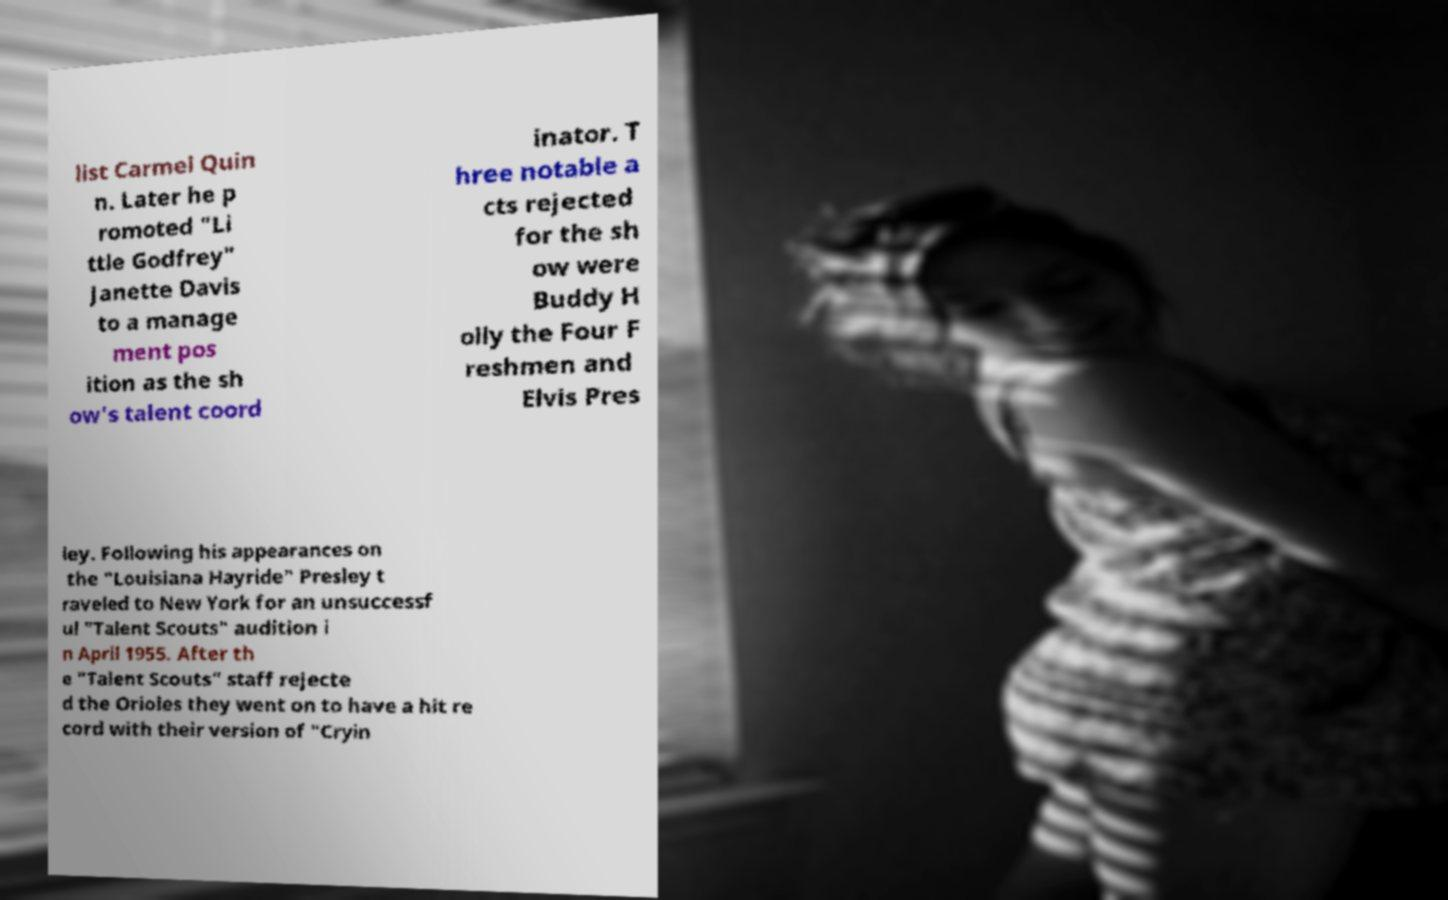Can you read and provide the text displayed in the image?This photo seems to have some interesting text. Can you extract and type it out for me? list Carmel Quin n. Later he p romoted "Li ttle Godfrey" Janette Davis to a manage ment pos ition as the sh ow's talent coord inator. T hree notable a cts rejected for the sh ow were Buddy H olly the Four F reshmen and Elvis Pres ley. Following his appearances on the "Louisiana Hayride" Presley t raveled to New York for an unsuccessf ul "Talent Scouts" audition i n April 1955. After th e "Talent Scouts" staff rejecte d the Orioles they went on to have a hit re cord with their version of "Cryin 